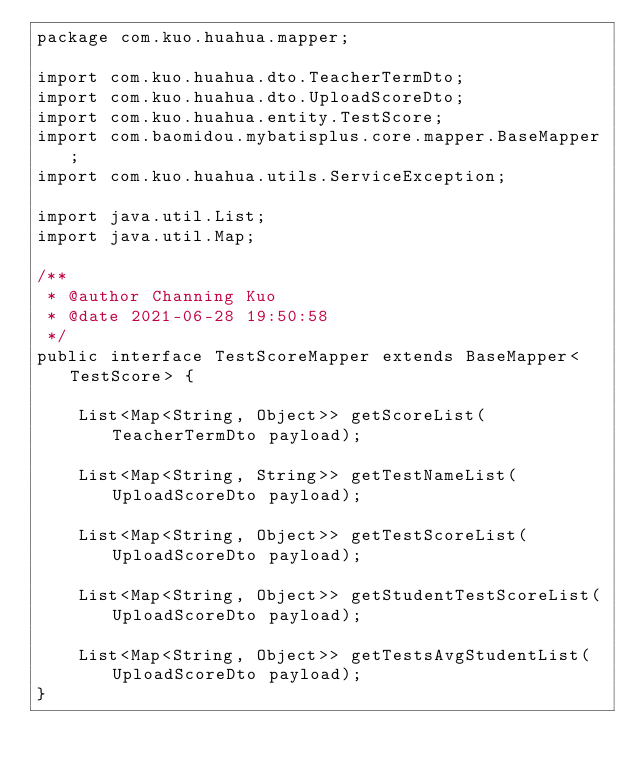Convert code to text. <code><loc_0><loc_0><loc_500><loc_500><_Java_>package com.kuo.huahua.mapper;

import com.kuo.huahua.dto.TeacherTermDto;
import com.kuo.huahua.dto.UploadScoreDto;
import com.kuo.huahua.entity.TestScore;
import com.baomidou.mybatisplus.core.mapper.BaseMapper;
import com.kuo.huahua.utils.ServiceException;

import java.util.List;
import java.util.Map;

/**
 * @author Channing Kuo
 * @date 2021-06-28 19:50:58
 */
public interface TestScoreMapper extends BaseMapper<TestScore> {

	List<Map<String, Object>> getScoreList(TeacherTermDto payload);

	List<Map<String, String>> getTestNameList(UploadScoreDto payload);

	List<Map<String, Object>> getTestScoreList(UploadScoreDto payload);

	List<Map<String, Object>> getStudentTestScoreList(UploadScoreDto payload);

	List<Map<String, Object>> getTestsAvgStudentList(UploadScoreDto payload);
}</code> 